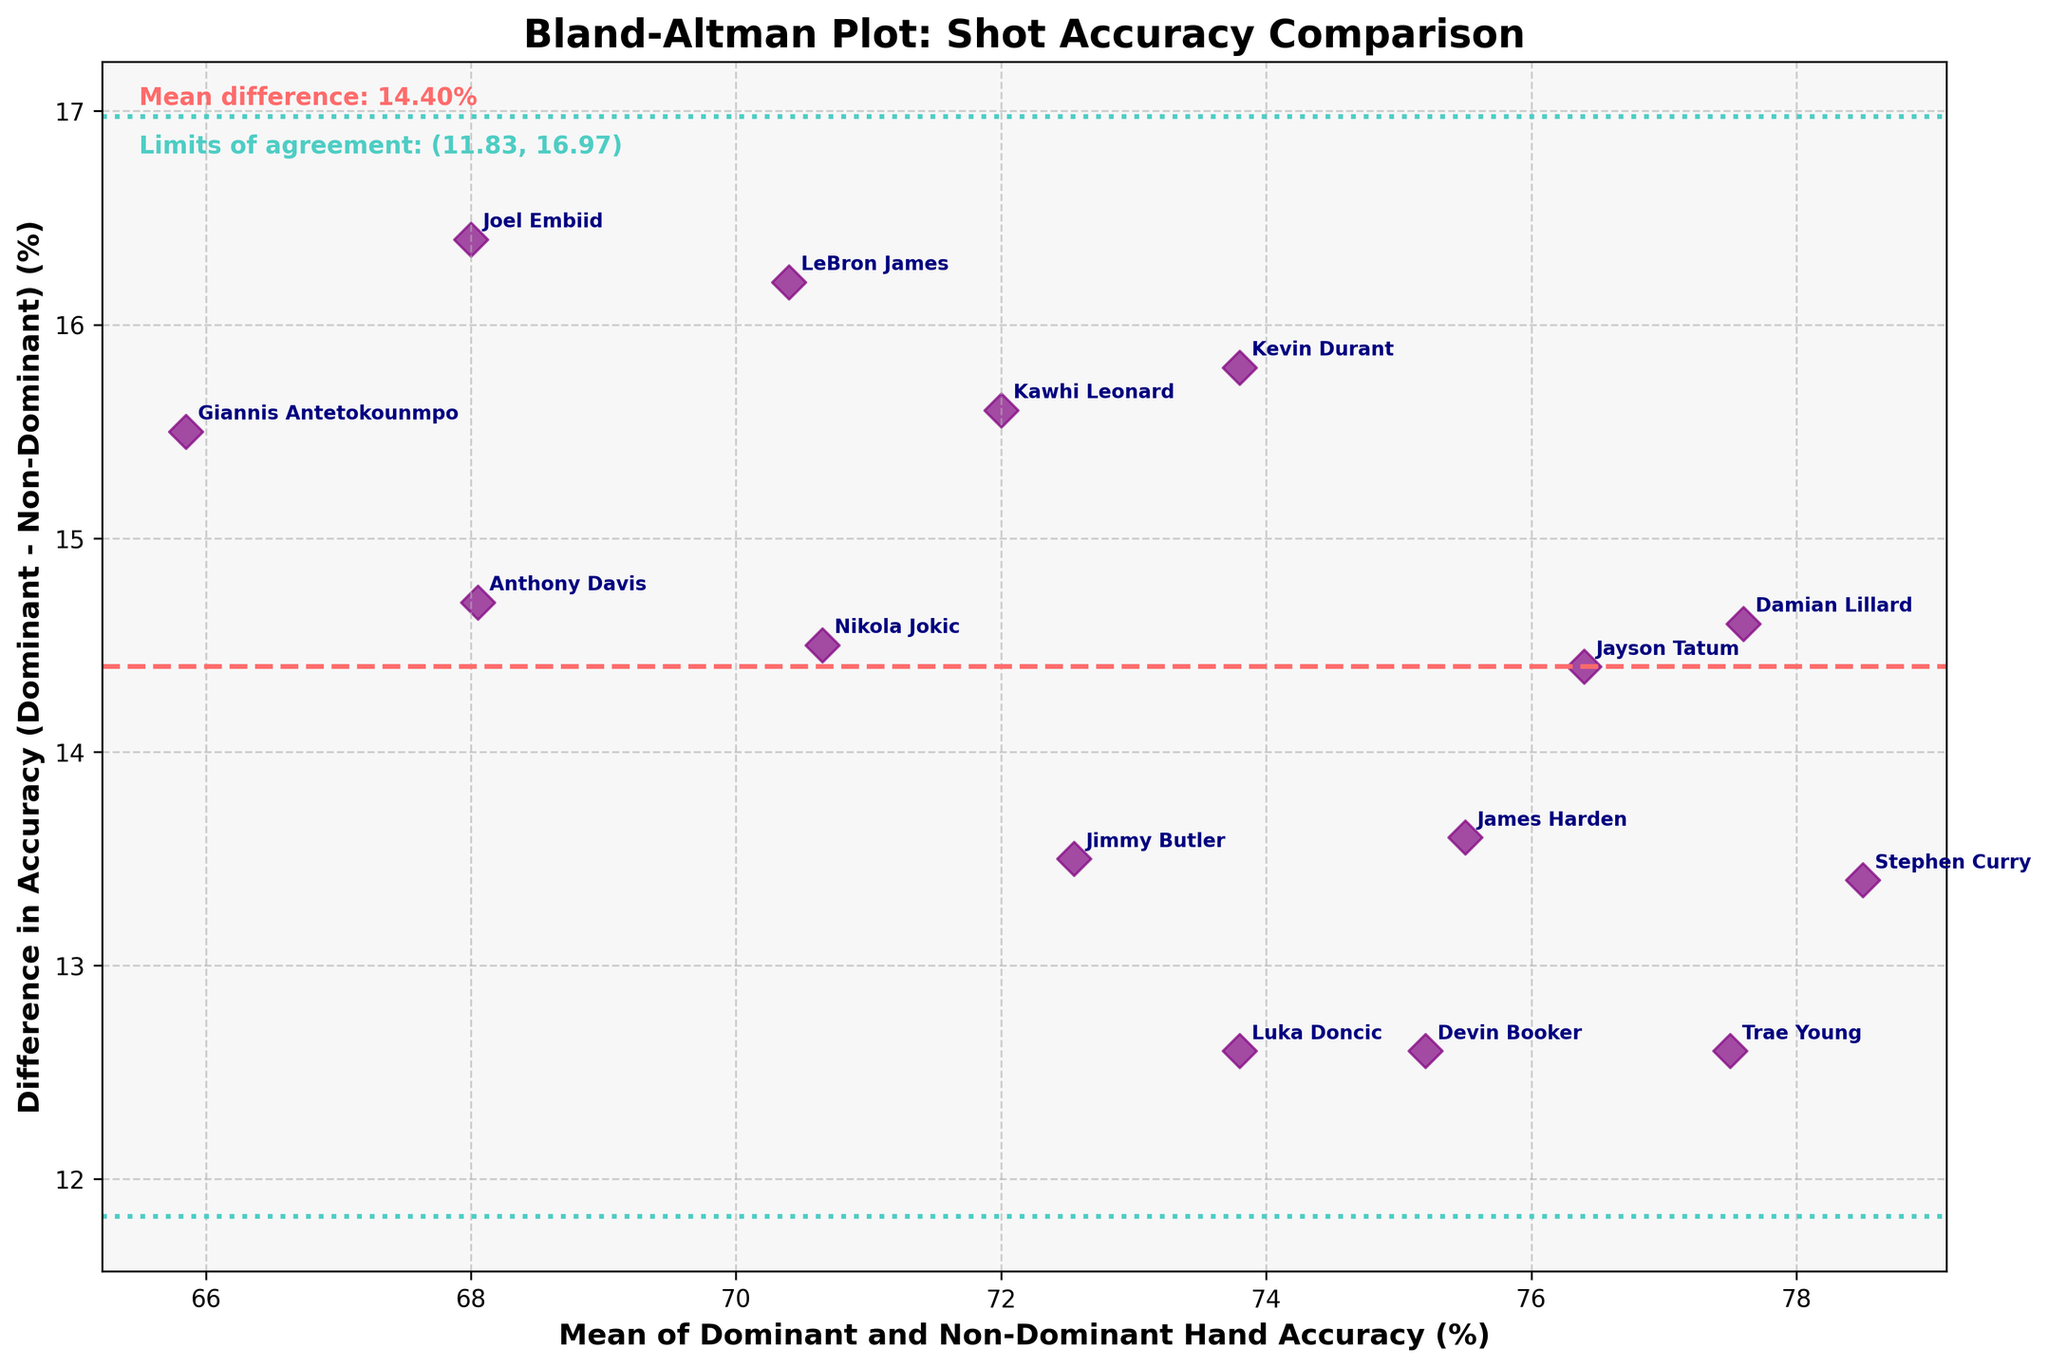How many data points are plotted on the figure? To determine the number of data points, count the number of individual data points (scatter markers) displayed on the plot. There are 15 individual markers.
Answer: 15 What is the mean difference in shot accuracy between dominant and non-dominant hands? The mean difference is indicated by a dashed horizontal line and is labeled textually. It reads "Mean difference: 14.50%".
Answer: 14.50% Which player has the largest difference in shot accuracy between their dominant and non-dominant hands? Label annotations beside each data point represent players. The point furthest above the mean difference line corresponds to Joel Embiid with a difference of 16.4%.
Answer: Joel Embiid What is the range of limits of agreement for the shot accuracy? The limits of agreement are represented by two lines and labeled textually. They are written as "Limits of agreement: (11.39, 17.61)".
Answer: (11.39, 17.61) Which player has the closest mean accuracy between their dominant and non-dominant hands to 80%? By observing the mean values on the x-axis, the player closest to 80% mean accuracy is Luka Doncic with a mean value of 80.1%.
Answer: Luka Doncic What does the horizontal line in the center of the plot represent? The horizontal line in the center of the plot represents the mean difference in shot accuracy between the dominant and non-dominant hands, which is labeled as 14.50%.
Answer: Mean difference How does the accuracy of Stephen Curry's dominant hand compare to his non-dominant hand? Stephen Curry's point annotation shows a difference of 13.4%. Given the dominant hand’s higher accuracy, it means his dominant hand is 13.4% more accurate than his non-dominant hand.
Answer: Dominant hand is 13.4% more accurate Which player’s data point lies closest to the lower limit of agreement? By observing the scatter around the lower limit of agreement, the closest point is that of Jimmy Butler. His difference is nearest to the lower limit of 11.39%.
Answer: Jimmy Butler What visual characteristics differentiate the limits of agreement lines from the mean difference line? The mean difference is represented by a dashed line, while the limits of agreement are shown as dotted lines. The mean difference line is red, whereas the limits of agreement lines are green.
Answer: Dashed red vs. dotted green Does Jayson Tatum's accuracy difference fall within the limits of agreement? Jayson Tatum’s point with a difference of 14.4% falls between the limits of agreement (11.39 and 17.61), indicating it is within the acceptable range.
Answer: Yes 